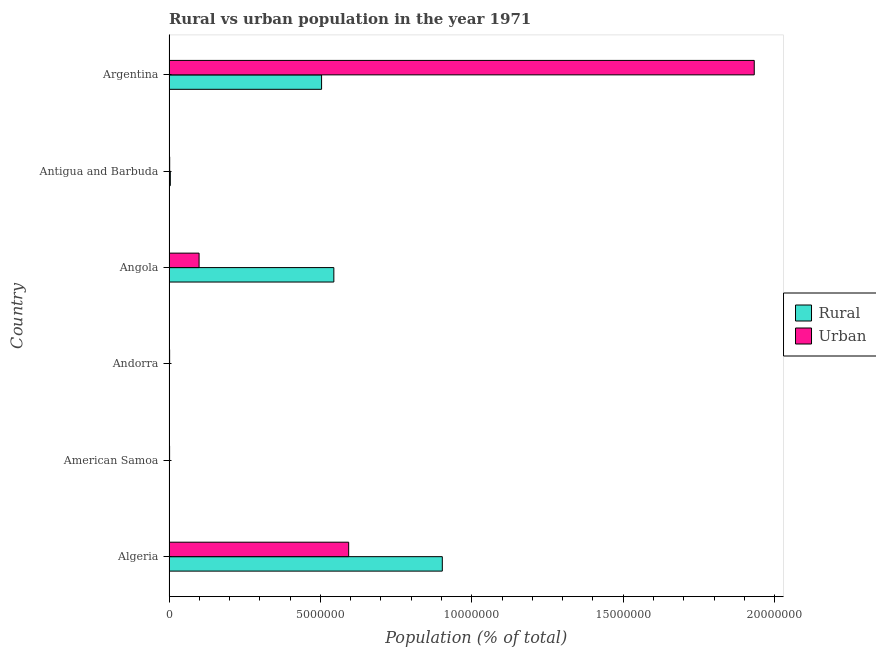How many bars are there on the 5th tick from the top?
Offer a very short reply. 2. How many bars are there on the 4th tick from the bottom?
Offer a very short reply. 2. What is the label of the 4th group of bars from the top?
Your answer should be compact. Andorra. In how many cases, is the number of bars for a given country not equal to the number of legend labels?
Give a very brief answer. 0. What is the rural population density in Angola?
Offer a terse response. 5.44e+06. Across all countries, what is the maximum rural population density?
Keep it short and to the point. 9.03e+06. Across all countries, what is the minimum urban population density?
Your answer should be compact. 1.98e+04. In which country was the rural population density maximum?
Offer a very short reply. Algeria. In which country was the urban population density minimum?
Make the answer very short. American Samoa. What is the total rural population density in the graph?
Ensure brevity in your answer.  1.96e+07. What is the difference between the urban population density in American Samoa and that in Argentina?
Provide a succinct answer. -1.93e+07. What is the difference between the rural population density in Andorra and the urban population density in Algeria?
Offer a terse response. -5.93e+06. What is the average rural population density per country?
Your response must be concise. 3.26e+06. What is the difference between the rural population density and urban population density in Argentina?
Your answer should be very brief. -1.43e+07. In how many countries, is the rural population density greater than 10000000 %?
Offer a terse response. 0. What is the difference between the highest and the second highest rural population density?
Your response must be concise. 3.58e+06. What is the difference between the highest and the lowest rural population density?
Offer a very short reply. 9.02e+06. Is the sum of the urban population density in Algeria and American Samoa greater than the maximum rural population density across all countries?
Offer a very short reply. No. What does the 1st bar from the top in Andorra represents?
Ensure brevity in your answer.  Urban. What does the 1st bar from the bottom in Angola represents?
Your answer should be compact. Rural. How many bars are there?
Your answer should be compact. 12. Are all the bars in the graph horizontal?
Make the answer very short. Yes. How many countries are there in the graph?
Provide a succinct answer. 6. Where does the legend appear in the graph?
Offer a terse response. Center right. How many legend labels are there?
Your response must be concise. 2. What is the title of the graph?
Provide a succinct answer. Rural vs urban population in the year 1971. What is the label or title of the X-axis?
Offer a terse response. Population (% of total). What is the Population (% of total) in Rural in Algeria?
Your answer should be very brief. 9.03e+06. What is the Population (% of total) of Urban in Algeria?
Make the answer very short. 5.93e+06. What is the Population (% of total) in Rural in American Samoa?
Give a very brief answer. 8156. What is the Population (% of total) of Urban in American Samoa?
Ensure brevity in your answer.  1.98e+04. What is the Population (% of total) in Rural in Andorra?
Make the answer very short. 4657. What is the Population (% of total) of Urban in Andorra?
Keep it short and to the point. 2.09e+04. What is the Population (% of total) of Rural in Angola?
Provide a succinct answer. 5.44e+06. What is the Population (% of total) of Urban in Angola?
Provide a succinct answer. 9.94e+05. What is the Population (% of total) of Rural in Antigua and Barbuda?
Ensure brevity in your answer.  4.39e+04. What is the Population (% of total) of Urban in Antigua and Barbuda?
Keep it short and to the point. 2.25e+04. What is the Population (% of total) of Rural in Argentina?
Provide a succinct answer. 5.04e+06. What is the Population (% of total) of Urban in Argentina?
Your response must be concise. 1.93e+07. Across all countries, what is the maximum Population (% of total) in Rural?
Keep it short and to the point. 9.03e+06. Across all countries, what is the maximum Population (% of total) in Urban?
Give a very brief answer. 1.93e+07. Across all countries, what is the minimum Population (% of total) in Rural?
Provide a short and direct response. 4657. Across all countries, what is the minimum Population (% of total) in Urban?
Provide a succinct answer. 1.98e+04. What is the total Population (% of total) in Rural in the graph?
Provide a succinct answer. 1.96e+07. What is the total Population (% of total) of Urban in the graph?
Make the answer very short. 2.63e+07. What is the difference between the Population (% of total) of Rural in Algeria and that in American Samoa?
Your answer should be compact. 9.02e+06. What is the difference between the Population (% of total) in Urban in Algeria and that in American Samoa?
Provide a short and direct response. 5.91e+06. What is the difference between the Population (% of total) in Rural in Algeria and that in Andorra?
Offer a terse response. 9.02e+06. What is the difference between the Population (% of total) of Urban in Algeria and that in Andorra?
Provide a succinct answer. 5.91e+06. What is the difference between the Population (% of total) of Rural in Algeria and that in Angola?
Provide a short and direct response. 3.58e+06. What is the difference between the Population (% of total) in Urban in Algeria and that in Angola?
Keep it short and to the point. 4.94e+06. What is the difference between the Population (% of total) of Rural in Algeria and that in Antigua and Barbuda?
Your response must be concise. 8.98e+06. What is the difference between the Population (% of total) of Urban in Algeria and that in Antigua and Barbuda?
Make the answer very short. 5.91e+06. What is the difference between the Population (% of total) of Rural in Algeria and that in Argentina?
Offer a very short reply. 3.99e+06. What is the difference between the Population (% of total) in Urban in Algeria and that in Argentina?
Ensure brevity in your answer.  -1.34e+07. What is the difference between the Population (% of total) of Rural in American Samoa and that in Andorra?
Offer a terse response. 3499. What is the difference between the Population (% of total) in Urban in American Samoa and that in Andorra?
Your answer should be very brief. -1143. What is the difference between the Population (% of total) in Rural in American Samoa and that in Angola?
Your answer should be compact. -5.44e+06. What is the difference between the Population (% of total) of Urban in American Samoa and that in Angola?
Offer a very short reply. -9.74e+05. What is the difference between the Population (% of total) in Rural in American Samoa and that in Antigua and Barbuda?
Your answer should be compact. -3.57e+04. What is the difference between the Population (% of total) of Urban in American Samoa and that in Antigua and Barbuda?
Make the answer very short. -2727. What is the difference between the Population (% of total) in Rural in American Samoa and that in Argentina?
Offer a terse response. -5.03e+06. What is the difference between the Population (% of total) in Urban in American Samoa and that in Argentina?
Offer a terse response. -1.93e+07. What is the difference between the Population (% of total) in Rural in Andorra and that in Angola?
Provide a short and direct response. -5.44e+06. What is the difference between the Population (% of total) of Urban in Andorra and that in Angola?
Offer a terse response. -9.73e+05. What is the difference between the Population (% of total) in Rural in Andorra and that in Antigua and Barbuda?
Offer a very short reply. -3.92e+04. What is the difference between the Population (% of total) in Urban in Andorra and that in Antigua and Barbuda?
Offer a very short reply. -1584. What is the difference between the Population (% of total) of Rural in Andorra and that in Argentina?
Keep it short and to the point. -5.03e+06. What is the difference between the Population (% of total) in Urban in Andorra and that in Argentina?
Give a very brief answer. -1.93e+07. What is the difference between the Population (% of total) in Rural in Angola and that in Antigua and Barbuda?
Ensure brevity in your answer.  5.40e+06. What is the difference between the Population (% of total) in Urban in Angola and that in Antigua and Barbuda?
Your answer should be compact. 9.71e+05. What is the difference between the Population (% of total) of Rural in Angola and that in Argentina?
Make the answer very short. 4.05e+05. What is the difference between the Population (% of total) in Urban in Angola and that in Argentina?
Offer a terse response. -1.83e+07. What is the difference between the Population (% of total) in Rural in Antigua and Barbuda and that in Argentina?
Make the answer very short. -4.99e+06. What is the difference between the Population (% of total) of Urban in Antigua and Barbuda and that in Argentina?
Offer a terse response. -1.93e+07. What is the difference between the Population (% of total) in Rural in Algeria and the Population (% of total) in Urban in American Samoa?
Your response must be concise. 9.01e+06. What is the difference between the Population (% of total) in Rural in Algeria and the Population (% of total) in Urban in Andorra?
Offer a very short reply. 9.01e+06. What is the difference between the Population (% of total) in Rural in Algeria and the Population (% of total) in Urban in Angola?
Keep it short and to the point. 8.03e+06. What is the difference between the Population (% of total) of Rural in Algeria and the Population (% of total) of Urban in Antigua and Barbuda?
Offer a terse response. 9.00e+06. What is the difference between the Population (% of total) in Rural in Algeria and the Population (% of total) in Urban in Argentina?
Keep it short and to the point. -1.03e+07. What is the difference between the Population (% of total) of Rural in American Samoa and the Population (% of total) of Urban in Andorra?
Offer a very short reply. -1.27e+04. What is the difference between the Population (% of total) of Rural in American Samoa and the Population (% of total) of Urban in Angola?
Ensure brevity in your answer.  -9.85e+05. What is the difference between the Population (% of total) in Rural in American Samoa and the Population (% of total) in Urban in Antigua and Barbuda?
Ensure brevity in your answer.  -1.43e+04. What is the difference between the Population (% of total) in Rural in American Samoa and the Population (% of total) in Urban in Argentina?
Your answer should be compact. -1.93e+07. What is the difference between the Population (% of total) of Rural in Andorra and the Population (% of total) of Urban in Angola?
Keep it short and to the point. -9.89e+05. What is the difference between the Population (% of total) of Rural in Andorra and the Population (% of total) of Urban in Antigua and Barbuda?
Provide a succinct answer. -1.78e+04. What is the difference between the Population (% of total) in Rural in Andorra and the Population (% of total) in Urban in Argentina?
Your answer should be compact. -1.93e+07. What is the difference between the Population (% of total) in Rural in Angola and the Population (% of total) in Urban in Antigua and Barbuda?
Keep it short and to the point. 5.42e+06. What is the difference between the Population (% of total) in Rural in Angola and the Population (% of total) in Urban in Argentina?
Your response must be concise. -1.39e+07. What is the difference between the Population (% of total) of Rural in Antigua and Barbuda and the Population (% of total) of Urban in Argentina?
Offer a terse response. -1.93e+07. What is the average Population (% of total) in Rural per country?
Ensure brevity in your answer.  3.26e+06. What is the average Population (% of total) of Urban per country?
Your response must be concise. 4.39e+06. What is the difference between the Population (% of total) in Rural and Population (% of total) in Urban in Algeria?
Offer a very short reply. 3.09e+06. What is the difference between the Population (% of total) in Rural and Population (% of total) in Urban in American Samoa?
Provide a succinct answer. -1.16e+04. What is the difference between the Population (% of total) of Rural and Population (% of total) of Urban in Andorra?
Offer a terse response. -1.62e+04. What is the difference between the Population (% of total) in Rural and Population (% of total) in Urban in Angola?
Your answer should be compact. 4.45e+06. What is the difference between the Population (% of total) of Rural and Population (% of total) of Urban in Antigua and Barbuda?
Give a very brief answer. 2.14e+04. What is the difference between the Population (% of total) in Rural and Population (% of total) in Urban in Argentina?
Keep it short and to the point. -1.43e+07. What is the ratio of the Population (% of total) in Rural in Algeria to that in American Samoa?
Give a very brief answer. 1106.69. What is the ratio of the Population (% of total) of Urban in Algeria to that in American Samoa?
Your answer should be compact. 300.3. What is the ratio of the Population (% of total) in Rural in Algeria to that in Andorra?
Provide a short and direct response. 1938.2. What is the ratio of the Population (% of total) in Urban in Algeria to that in Andorra?
Ensure brevity in your answer.  283.88. What is the ratio of the Population (% of total) of Rural in Algeria to that in Angola?
Provide a succinct answer. 1.66. What is the ratio of the Population (% of total) of Urban in Algeria to that in Angola?
Offer a terse response. 5.97. What is the ratio of the Population (% of total) in Rural in Algeria to that in Antigua and Barbuda?
Give a very brief answer. 205.84. What is the ratio of the Population (% of total) in Urban in Algeria to that in Antigua and Barbuda?
Your answer should be very brief. 263.88. What is the ratio of the Population (% of total) of Rural in Algeria to that in Argentina?
Make the answer very short. 1.79. What is the ratio of the Population (% of total) in Urban in Algeria to that in Argentina?
Offer a very short reply. 0.31. What is the ratio of the Population (% of total) of Rural in American Samoa to that in Andorra?
Provide a short and direct response. 1.75. What is the ratio of the Population (% of total) in Urban in American Samoa to that in Andorra?
Provide a short and direct response. 0.95. What is the ratio of the Population (% of total) of Rural in American Samoa to that in Angola?
Your answer should be compact. 0. What is the ratio of the Population (% of total) of Urban in American Samoa to that in Angola?
Your response must be concise. 0.02. What is the ratio of the Population (% of total) in Rural in American Samoa to that in Antigua and Barbuda?
Provide a short and direct response. 0.19. What is the ratio of the Population (% of total) in Urban in American Samoa to that in Antigua and Barbuda?
Keep it short and to the point. 0.88. What is the ratio of the Population (% of total) in Rural in American Samoa to that in Argentina?
Offer a terse response. 0. What is the ratio of the Population (% of total) of Rural in Andorra to that in Angola?
Provide a short and direct response. 0. What is the ratio of the Population (% of total) in Urban in Andorra to that in Angola?
Your response must be concise. 0.02. What is the ratio of the Population (% of total) in Rural in Andorra to that in Antigua and Barbuda?
Give a very brief answer. 0.11. What is the ratio of the Population (% of total) in Urban in Andorra to that in Antigua and Barbuda?
Make the answer very short. 0.93. What is the ratio of the Population (% of total) in Rural in Andorra to that in Argentina?
Provide a short and direct response. 0. What is the ratio of the Population (% of total) in Urban in Andorra to that in Argentina?
Make the answer very short. 0. What is the ratio of the Population (% of total) in Rural in Angola to that in Antigua and Barbuda?
Keep it short and to the point. 124.15. What is the ratio of the Population (% of total) in Urban in Angola to that in Antigua and Barbuda?
Your answer should be very brief. 44.18. What is the ratio of the Population (% of total) of Rural in Angola to that in Argentina?
Offer a very short reply. 1.08. What is the ratio of the Population (% of total) of Urban in Angola to that in Argentina?
Your response must be concise. 0.05. What is the ratio of the Population (% of total) of Rural in Antigua and Barbuda to that in Argentina?
Your response must be concise. 0.01. What is the ratio of the Population (% of total) of Urban in Antigua and Barbuda to that in Argentina?
Ensure brevity in your answer.  0. What is the difference between the highest and the second highest Population (% of total) of Rural?
Your response must be concise. 3.58e+06. What is the difference between the highest and the second highest Population (% of total) in Urban?
Give a very brief answer. 1.34e+07. What is the difference between the highest and the lowest Population (% of total) of Rural?
Ensure brevity in your answer.  9.02e+06. What is the difference between the highest and the lowest Population (% of total) in Urban?
Your response must be concise. 1.93e+07. 